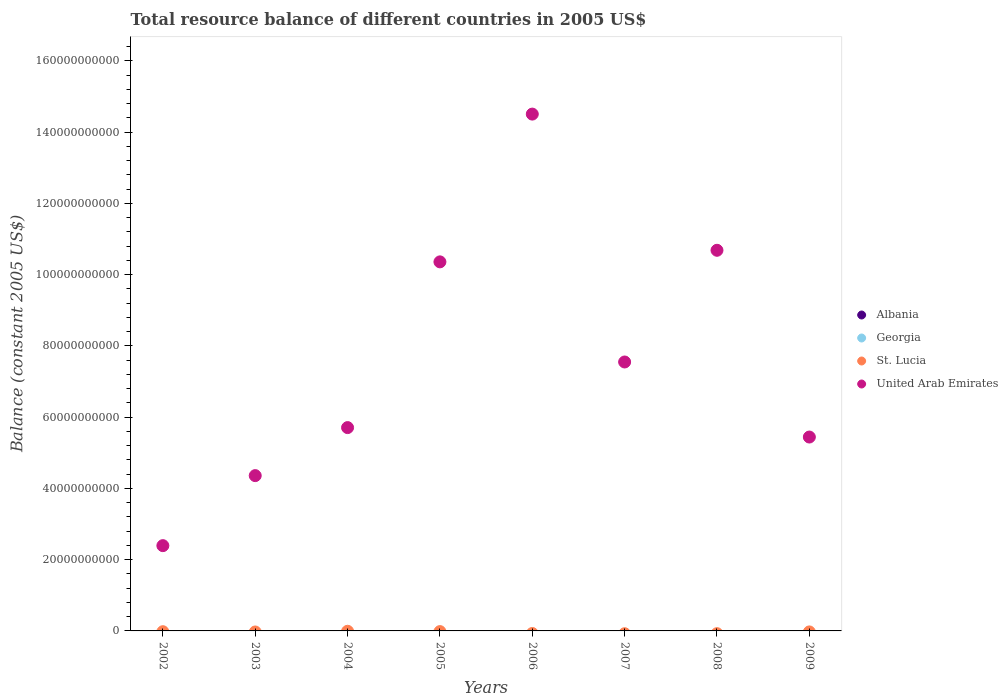Is the number of dotlines equal to the number of legend labels?
Give a very brief answer. No. Across all years, what is the maximum total resource balance in United Arab Emirates?
Make the answer very short. 1.45e+11. Across all years, what is the minimum total resource balance in United Arab Emirates?
Keep it short and to the point. 2.39e+1. What is the total total resource balance in United Arab Emirates in the graph?
Make the answer very short. 6.10e+11. What is the difference between the total resource balance in United Arab Emirates in 2006 and that in 2009?
Your response must be concise. 9.07e+1. What is the difference between the total resource balance in Georgia in 2006 and the total resource balance in United Arab Emirates in 2003?
Give a very brief answer. -4.36e+1. What is the average total resource balance in Albania per year?
Offer a very short reply. 0. What is the ratio of the total resource balance in United Arab Emirates in 2003 to that in 2005?
Provide a succinct answer. 0.42. Is the total resource balance in United Arab Emirates in 2004 less than that in 2009?
Your answer should be very brief. No. What is the difference between the highest and the lowest total resource balance in United Arab Emirates?
Offer a terse response. 1.21e+11. Is the sum of the total resource balance in United Arab Emirates in 2003 and 2004 greater than the maximum total resource balance in Georgia across all years?
Ensure brevity in your answer.  Yes. Is the total resource balance in Georgia strictly greater than the total resource balance in United Arab Emirates over the years?
Keep it short and to the point. No. How many dotlines are there?
Ensure brevity in your answer.  1. What is the difference between two consecutive major ticks on the Y-axis?
Offer a terse response. 2.00e+1. Does the graph contain grids?
Provide a short and direct response. No. How are the legend labels stacked?
Your answer should be compact. Vertical. What is the title of the graph?
Provide a short and direct response. Total resource balance of different countries in 2005 US$. Does "Czech Republic" appear as one of the legend labels in the graph?
Provide a succinct answer. No. What is the label or title of the Y-axis?
Give a very brief answer. Balance (constant 2005 US$). What is the Balance (constant 2005 US$) of Albania in 2002?
Ensure brevity in your answer.  0. What is the Balance (constant 2005 US$) of Georgia in 2002?
Provide a succinct answer. 0. What is the Balance (constant 2005 US$) of St. Lucia in 2002?
Make the answer very short. 0. What is the Balance (constant 2005 US$) of United Arab Emirates in 2002?
Make the answer very short. 2.39e+1. What is the Balance (constant 2005 US$) in United Arab Emirates in 2003?
Your answer should be very brief. 4.36e+1. What is the Balance (constant 2005 US$) in United Arab Emirates in 2004?
Ensure brevity in your answer.  5.71e+1. What is the Balance (constant 2005 US$) of St. Lucia in 2005?
Offer a terse response. 0. What is the Balance (constant 2005 US$) in United Arab Emirates in 2005?
Make the answer very short. 1.04e+11. What is the Balance (constant 2005 US$) of United Arab Emirates in 2006?
Your answer should be compact. 1.45e+11. What is the Balance (constant 2005 US$) of St. Lucia in 2007?
Ensure brevity in your answer.  0. What is the Balance (constant 2005 US$) of United Arab Emirates in 2007?
Make the answer very short. 7.55e+1. What is the Balance (constant 2005 US$) of St. Lucia in 2008?
Provide a short and direct response. 0. What is the Balance (constant 2005 US$) of United Arab Emirates in 2008?
Give a very brief answer. 1.07e+11. What is the Balance (constant 2005 US$) of St. Lucia in 2009?
Your answer should be very brief. 0. What is the Balance (constant 2005 US$) in United Arab Emirates in 2009?
Ensure brevity in your answer.  5.44e+1. Across all years, what is the maximum Balance (constant 2005 US$) in United Arab Emirates?
Your answer should be very brief. 1.45e+11. Across all years, what is the minimum Balance (constant 2005 US$) in United Arab Emirates?
Your answer should be very brief. 2.39e+1. What is the total Balance (constant 2005 US$) of Albania in the graph?
Offer a terse response. 0. What is the total Balance (constant 2005 US$) of United Arab Emirates in the graph?
Offer a terse response. 6.10e+11. What is the difference between the Balance (constant 2005 US$) of United Arab Emirates in 2002 and that in 2003?
Offer a very short reply. -1.97e+1. What is the difference between the Balance (constant 2005 US$) of United Arab Emirates in 2002 and that in 2004?
Give a very brief answer. -3.31e+1. What is the difference between the Balance (constant 2005 US$) of United Arab Emirates in 2002 and that in 2005?
Give a very brief answer. -7.97e+1. What is the difference between the Balance (constant 2005 US$) of United Arab Emirates in 2002 and that in 2006?
Keep it short and to the point. -1.21e+11. What is the difference between the Balance (constant 2005 US$) in United Arab Emirates in 2002 and that in 2007?
Your answer should be very brief. -5.16e+1. What is the difference between the Balance (constant 2005 US$) in United Arab Emirates in 2002 and that in 2008?
Offer a terse response. -8.29e+1. What is the difference between the Balance (constant 2005 US$) of United Arab Emirates in 2002 and that in 2009?
Offer a very short reply. -3.05e+1. What is the difference between the Balance (constant 2005 US$) of United Arab Emirates in 2003 and that in 2004?
Keep it short and to the point. -1.35e+1. What is the difference between the Balance (constant 2005 US$) in United Arab Emirates in 2003 and that in 2005?
Your response must be concise. -6.00e+1. What is the difference between the Balance (constant 2005 US$) in United Arab Emirates in 2003 and that in 2006?
Offer a terse response. -1.01e+11. What is the difference between the Balance (constant 2005 US$) of United Arab Emirates in 2003 and that in 2007?
Provide a short and direct response. -3.19e+1. What is the difference between the Balance (constant 2005 US$) of United Arab Emirates in 2003 and that in 2008?
Keep it short and to the point. -6.33e+1. What is the difference between the Balance (constant 2005 US$) of United Arab Emirates in 2003 and that in 2009?
Ensure brevity in your answer.  -1.08e+1. What is the difference between the Balance (constant 2005 US$) in United Arab Emirates in 2004 and that in 2005?
Provide a short and direct response. -4.65e+1. What is the difference between the Balance (constant 2005 US$) of United Arab Emirates in 2004 and that in 2006?
Offer a terse response. -8.80e+1. What is the difference between the Balance (constant 2005 US$) of United Arab Emirates in 2004 and that in 2007?
Provide a succinct answer. -1.84e+1. What is the difference between the Balance (constant 2005 US$) of United Arab Emirates in 2004 and that in 2008?
Offer a terse response. -4.98e+1. What is the difference between the Balance (constant 2005 US$) in United Arab Emirates in 2004 and that in 2009?
Keep it short and to the point. 2.65e+09. What is the difference between the Balance (constant 2005 US$) of United Arab Emirates in 2005 and that in 2006?
Your response must be concise. -4.15e+1. What is the difference between the Balance (constant 2005 US$) of United Arab Emirates in 2005 and that in 2007?
Offer a very short reply. 2.81e+1. What is the difference between the Balance (constant 2005 US$) of United Arab Emirates in 2005 and that in 2008?
Your response must be concise. -3.25e+09. What is the difference between the Balance (constant 2005 US$) of United Arab Emirates in 2005 and that in 2009?
Keep it short and to the point. 4.92e+1. What is the difference between the Balance (constant 2005 US$) in United Arab Emirates in 2006 and that in 2007?
Offer a very short reply. 6.96e+1. What is the difference between the Balance (constant 2005 US$) in United Arab Emirates in 2006 and that in 2008?
Give a very brief answer. 3.82e+1. What is the difference between the Balance (constant 2005 US$) in United Arab Emirates in 2006 and that in 2009?
Offer a terse response. 9.07e+1. What is the difference between the Balance (constant 2005 US$) in United Arab Emirates in 2007 and that in 2008?
Your answer should be very brief. -3.14e+1. What is the difference between the Balance (constant 2005 US$) in United Arab Emirates in 2007 and that in 2009?
Provide a succinct answer. 2.11e+1. What is the difference between the Balance (constant 2005 US$) of United Arab Emirates in 2008 and that in 2009?
Offer a very short reply. 5.24e+1. What is the average Balance (constant 2005 US$) of Georgia per year?
Provide a short and direct response. 0. What is the average Balance (constant 2005 US$) of United Arab Emirates per year?
Give a very brief answer. 7.63e+1. What is the ratio of the Balance (constant 2005 US$) in United Arab Emirates in 2002 to that in 2003?
Your answer should be compact. 0.55. What is the ratio of the Balance (constant 2005 US$) in United Arab Emirates in 2002 to that in 2004?
Offer a very short reply. 0.42. What is the ratio of the Balance (constant 2005 US$) of United Arab Emirates in 2002 to that in 2005?
Offer a very short reply. 0.23. What is the ratio of the Balance (constant 2005 US$) of United Arab Emirates in 2002 to that in 2006?
Offer a terse response. 0.17. What is the ratio of the Balance (constant 2005 US$) in United Arab Emirates in 2002 to that in 2007?
Offer a terse response. 0.32. What is the ratio of the Balance (constant 2005 US$) of United Arab Emirates in 2002 to that in 2008?
Offer a terse response. 0.22. What is the ratio of the Balance (constant 2005 US$) of United Arab Emirates in 2002 to that in 2009?
Offer a very short reply. 0.44. What is the ratio of the Balance (constant 2005 US$) in United Arab Emirates in 2003 to that in 2004?
Ensure brevity in your answer.  0.76. What is the ratio of the Balance (constant 2005 US$) in United Arab Emirates in 2003 to that in 2005?
Provide a short and direct response. 0.42. What is the ratio of the Balance (constant 2005 US$) of United Arab Emirates in 2003 to that in 2006?
Offer a terse response. 0.3. What is the ratio of the Balance (constant 2005 US$) in United Arab Emirates in 2003 to that in 2007?
Provide a short and direct response. 0.58. What is the ratio of the Balance (constant 2005 US$) of United Arab Emirates in 2003 to that in 2008?
Keep it short and to the point. 0.41. What is the ratio of the Balance (constant 2005 US$) of United Arab Emirates in 2003 to that in 2009?
Your response must be concise. 0.8. What is the ratio of the Balance (constant 2005 US$) in United Arab Emirates in 2004 to that in 2005?
Provide a short and direct response. 0.55. What is the ratio of the Balance (constant 2005 US$) of United Arab Emirates in 2004 to that in 2006?
Keep it short and to the point. 0.39. What is the ratio of the Balance (constant 2005 US$) in United Arab Emirates in 2004 to that in 2007?
Give a very brief answer. 0.76. What is the ratio of the Balance (constant 2005 US$) of United Arab Emirates in 2004 to that in 2008?
Make the answer very short. 0.53. What is the ratio of the Balance (constant 2005 US$) of United Arab Emirates in 2004 to that in 2009?
Keep it short and to the point. 1.05. What is the ratio of the Balance (constant 2005 US$) of United Arab Emirates in 2005 to that in 2006?
Provide a short and direct response. 0.71. What is the ratio of the Balance (constant 2005 US$) in United Arab Emirates in 2005 to that in 2007?
Your answer should be very brief. 1.37. What is the ratio of the Balance (constant 2005 US$) in United Arab Emirates in 2005 to that in 2008?
Your answer should be very brief. 0.97. What is the ratio of the Balance (constant 2005 US$) in United Arab Emirates in 2005 to that in 2009?
Provide a short and direct response. 1.9. What is the ratio of the Balance (constant 2005 US$) in United Arab Emirates in 2006 to that in 2007?
Offer a terse response. 1.92. What is the ratio of the Balance (constant 2005 US$) in United Arab Emirates in 2006 to that in 2008?
Give a very brief answer. 1.36. What is the ratio of the Balance (constant 2005 US$) of United Arab Emirates in 2006 to that in 2009?
Offer a terse response. 2.67. What is the ratio of the Balance (constant 2005 US$) of United Arab Emirates in 2007 to that in 2008?
Keep it short and to the point. 0.71. What is the ratio of the Balance (constant 2005 US$) in United Arab Emirates in 2007 to that in 2009?
Keep it short and to the point. 1.39. What is the ratio of the Balance (constant 2005 US$) in United Arab Emirates in 2008 to that in 2009?
Provide a succinct answer. 1.96. What is the difference between the highest and the second highest Balance (constant 2005 US$) of United Arab Emirates?
Give a very brief answer. 3.82e+1. What is the difference between the highest and the lowest Balance (constant 2005 US$) in United Arab Emirates?
Keep it short and to the point. 1.21e+11. 